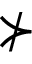<formula> <loc_0><loc_0><loc_500><loc_500>\nsucc</formula> 